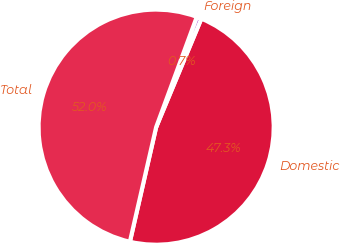<chart> <loc_0><loc_0><loc_500><loc_500><pie_chart><fcel>Domestic<fcel>Foreign<fcel>Total<nl><fcel>47.31%<fcel>0.66%<fcel>52.04%<nl></chart> 